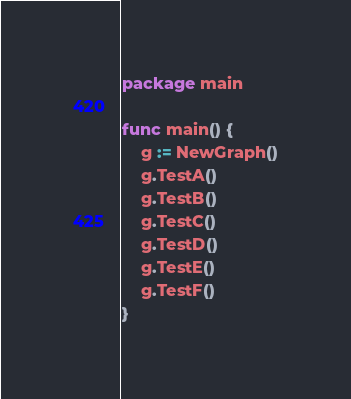Convert code to text. <code><loc_0><loc_0><loc_500><loc_500><_Go_>package main

func main() {
	g := NewGraph()
	g.TestA()
	g.TestB()
	g.TestC()
	g.TestD()
	g.TestE()
	g.TestF()
}
</code> 